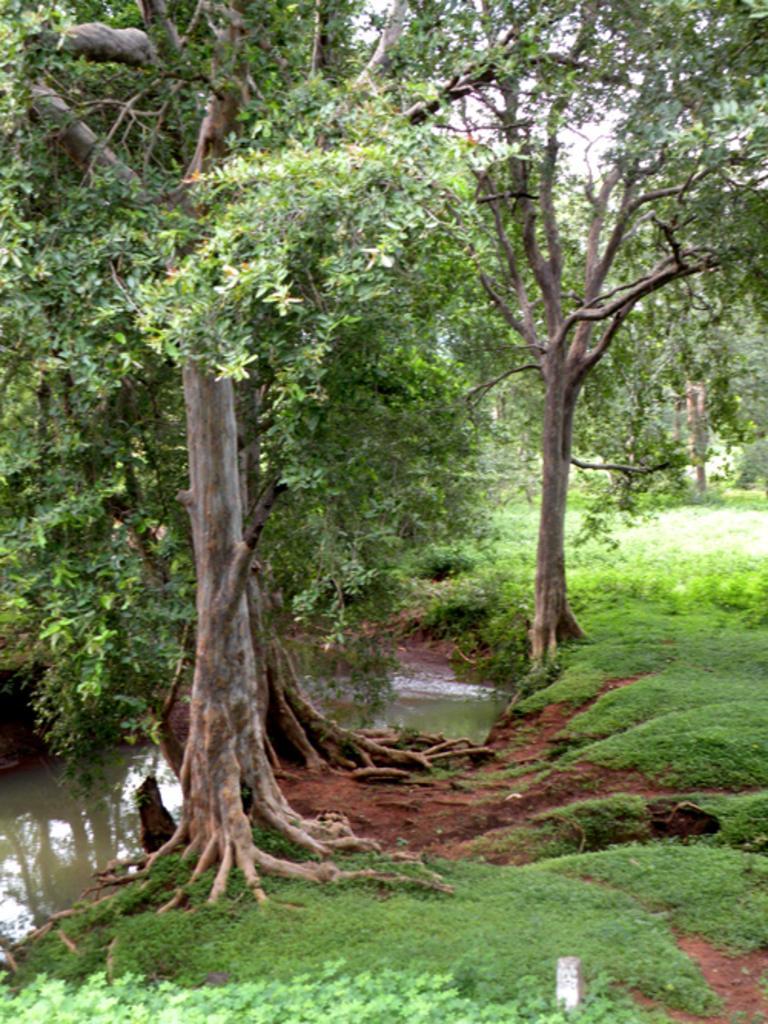How would you summarize this image in a sentence or two? In this picture we can see water, trees, grass and we can see sky in the background. 